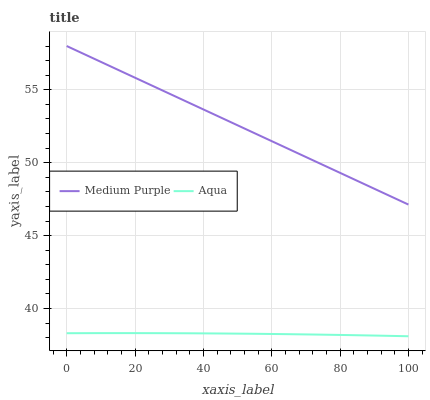Does Aqua have the minimum area under the curve?
Answer yes or no. Yes. Does Medium Purple have the maximum area under the curve?
Answer yes or no. Yes. Does Aqua have the maximum area under the curve?
Answer yes or no. No. Is Medium Purple the smoothest?
Answer yes or no. Yes. Is Aqua the roughest?
Answer yes or no. Yes. Is Aqua the smoothest?
Answer yes or no. No. Does Medium Purple have the highest value?
Answer yes or no. Yes. Does Aqua have the highest value?
Answer yes or no. No. Is Aqua less than Medium Purple?
Answer yes or no. Yes. Is Medium Purple greater than Aqua?
Answer yes or no. Yes. Does Aqua intersect Medium Purple?
Answer yes or no. No. 